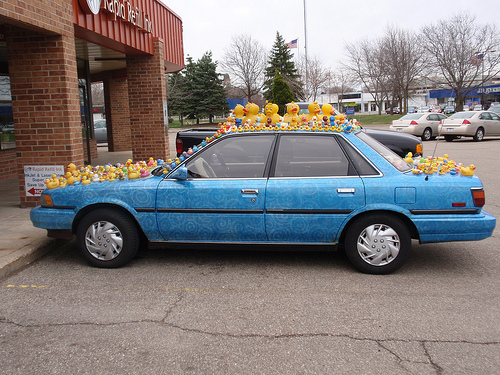<image>
Can you confirm if the rubber duck is on the car? Yes. Looking at the image, I can see the rubber duck is positioned on top of the car, with the car providing support. 